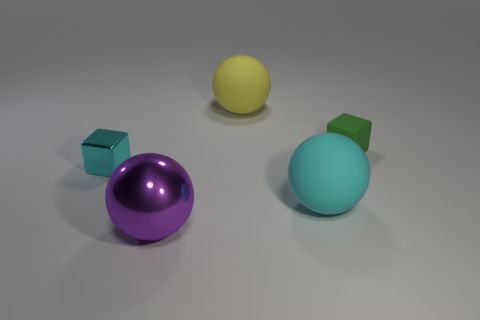Do the objects appear to have any texture? The objects seem to have a sleek, shiny texture, particularly noticeable in the reflections and highlights on the spheres, which suggests that they are made of a glossy material. 